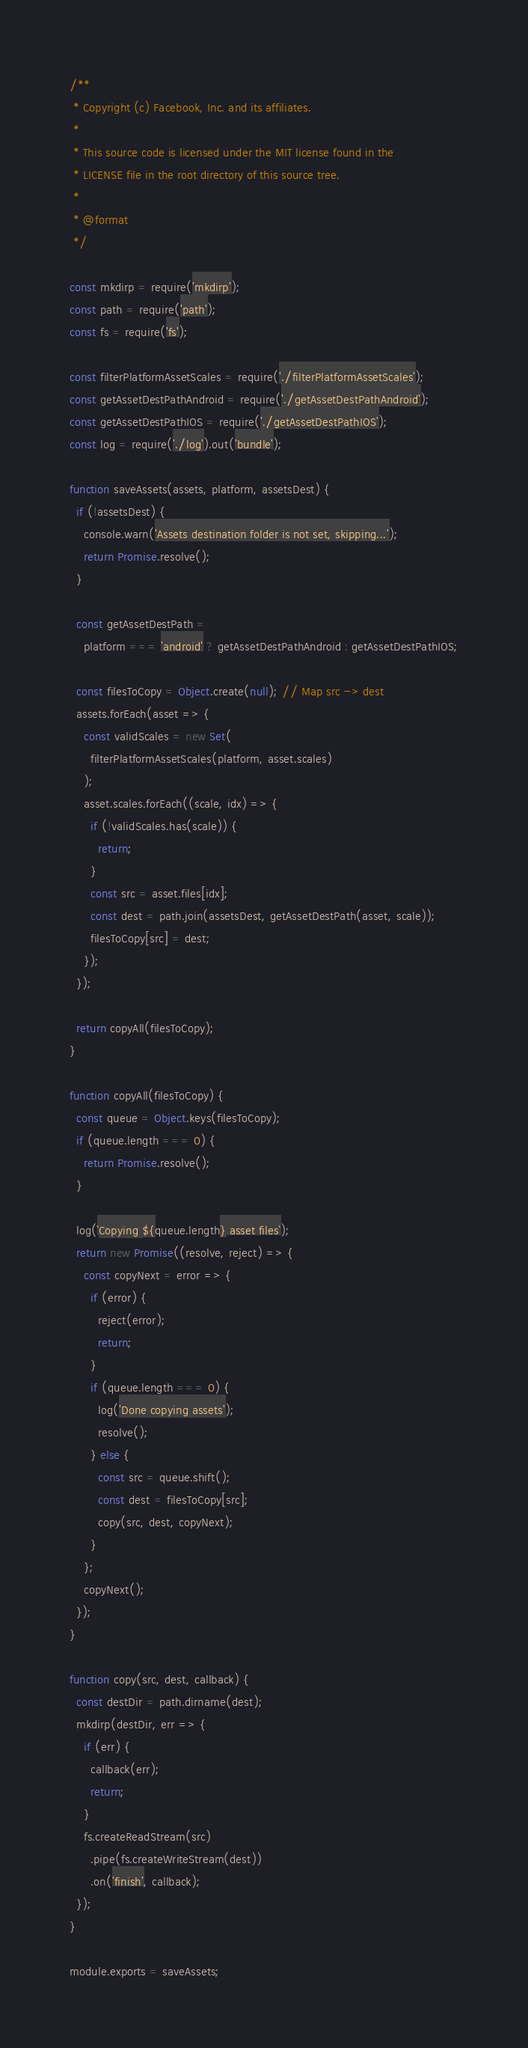Convert code to text. <code><loc_0><loc_0><loc_500><loc_500><_JavaScript_>/**
 * Copyright (c) Facebook, Inc. and its affiliates.
 *
 * This source code is licensed under the MIT license found in the
 * LICENSE file in the root directory of this source tree.
 *
 * @format
 */

const mkdirp = require('mkdirp');
const path = require('path');
const fs = require('fs');

const filterPlatformAssetScales = require('./filterPlatformAssetScales');
const getAssetDestPathAndroid = require('./getAssetDestPathAndroid');
const getAssetDestPathIOS = require('./getAssetDestPathIOS');
const log = require('./log').out('bundle');

function saveAssets(assets, platform, assetsDest) {
  if (!assetsDest) {
    console.warn('Assets destination folder is not set, skipping...');
    return Promise.resolve();
  }

  const getAssetDestPath =
    platform === 'android' ? getAssetDestPathAndroid : getAssetDestPathIOS;

  const filesToCopy = Object.create(null); // Map src -> dest
  assets.forEach(asset => {
    const validScales = new Set(
      filterPlatformAssetScales(platform, asset.scales)
    );
    asset.scales.forEach((scale, idx) => {
      if (!validScales.has(scale)) {
        return;
      }
      const src = asset.files[idx];
      const dest = path.join(assetsDest, getAssetDestPath(asset, scale));
      filesToCopy[src] = dest;
    });
  });

  return copyAll(filesToCopy);
}

function copyAll(filesToCopy) {
  const queue = Object.keys(filesToCopy);
  if (queue.length === 0) {
    return Promise.resolve();
  }

  log(`Copying ${queue.length} asset files`);
  return new Promise((resolve, reject) => {
    const copyNext = error => {
      if (error) {
        reject(error);
        return;
      }
      if (queue.length === 0) {
        log('Done copying assets');
        resolve();
      } else {
        const src = queue.shift();
        const dest = filesToCopy[src];
        copy(src, dest, copyNext);
      }
    };
    copyNext();
  });
}

function copy(src, dest, callback) {
  const destDir = path.dirname(dest);
  mkdirp(destDir, err => {
    if (err) {
      callback(err);
      return;
    }
    fs.createReadStream(src)
      .pipe(fs.createWriteStream(dest))
      .on('finish', callback);
  });
}

module.exports = saveAssets;
</code> 